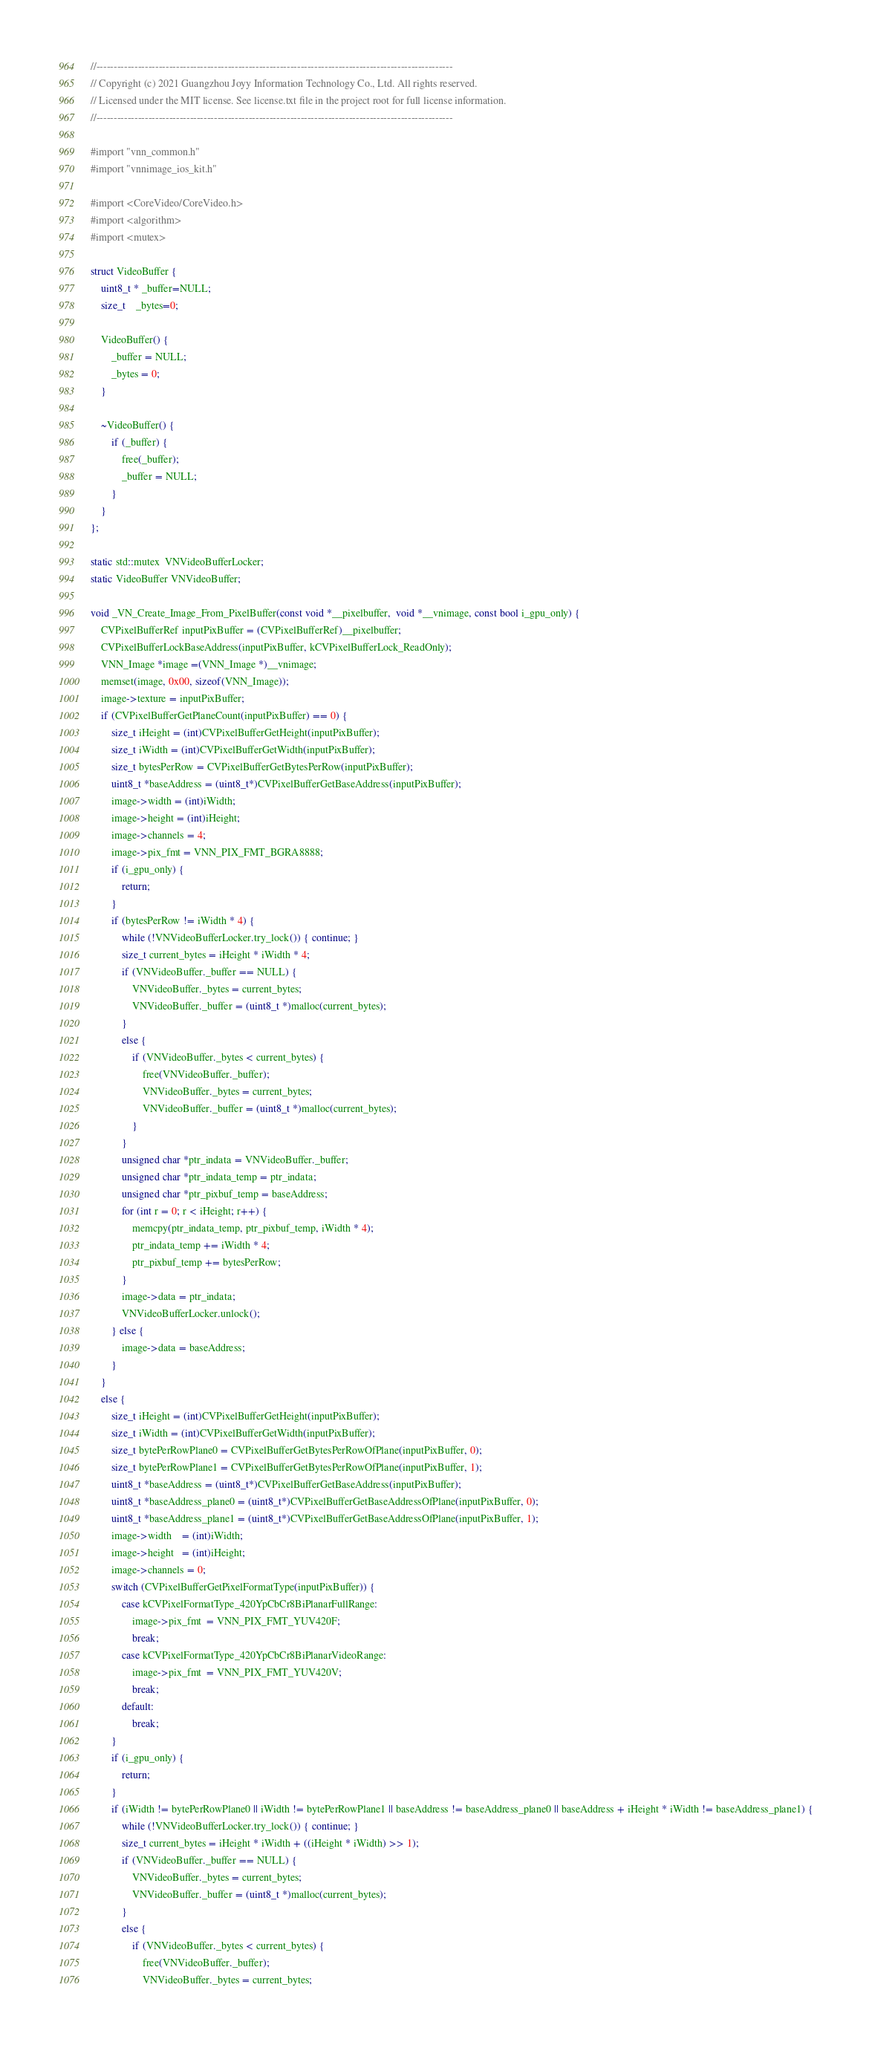<code> <loc_0><loc_0><loc_500><loc_500><_ObjectiveC_>//-------------------------------------------------------------------------------------------------------
// Copyright (c) 2021 Guangzhou Joyy Information Technology Co., Ltd. All rights reserved.
// Licensed under the MIT license. See license.txt file in the project root for full license information.
//-------------------------------------------------------------------------------------------------------

#import "vnn_common.h"
#import "vnnimage_ios_kit.h"

#import <CoreVideo/CoreVideo.h>
#import <algorithm>
#import <mutex>

struct VideoBuffer {
    uint8_t * _buffer=NULL;
    size_t    _bytes=0;

    VideoBuffer() {
        _buffer = NULL;
        _bytes = 0;
    }

    ~VideoBuffer() {
        if (_buffer) {
            free(_buffer);
            _buffer = NULL;
        }
    }
};

static std::mutex  VNVideoBufferLocker;
static VideoBuffer VNVideoBuffer;

void _VN_Create_Image_From_PixelBuffer(const void *__pixelbuffer,  void *__vnimage, const bool i_gpu_only) {
    CVPixelBufferRef inputPixBuffer = (CVPixelBufferRef)__pixelbuffer;
    CVPixelBufferLockBaseAddress(inputPixBuffer, kCVPixelBufferLock_ReadOnly);
    VNN_Image *image =(VNN_Image *)__vnimage;
	memset(image, 0x00, sizeof(VNN_Image));
    image->texture = inputPixBuffer;
	if (CVPixelBufferGetPlaneCount(inputPixBuffer) == 0) {
		size_t iHeight = (int)CVPixelBufferGetHeight(inputPixBuffer);
		size_t iWidth = (int)CVPixelBufferGetWidth(inputPixBuffer);
		size_t bytesPerRow = CVPixelBufferGetBytesPerRow(inputPixBuffer);
		uint8_t *baseAddress = (uint8_t*)CVPixelBufferGetBaseAddress(inputPixBuffer);
		image->width = (int)iWidth;
		image->height = (int)iHeight;
		image->channels = 4;
		image->pix_fmt = VNN_PIX_FMT_BGRA8888;
        if (i_gpu_only) {
            return;
        }
		if (bytesPerRow != iWidth * 4) {
            while (!VNVideoBufferLocker.try_lock()) { continue; }
            size_t current_bytes = iHeight * iWidth * 4;
            if (VNVideoBuffer._buffer == NULL) {
                VNVideoBuffer._bytes = current_bytes;
                VNVideoBuffer._buffer = (uint8_t *)malloc(current_bytes);
            }
            else {
                if (VNVideoBuffer._bytes < current_bytes) {
                    free(VNVideoBuffer._buffer);
                    VNVideoBuffer._bytes = current_bytes;
                    VNVideoBuffer._buffer = (uint8_t *)malloc(current_bytes);
                }
            }
			unsigned char *ptr_indata = VNVideoBuffer._buffer;
			unsigned char *ptr_indata_temp = ptr_indata;
			unsigned char *ptr_pixbuf_temp = baseAddress;
			for (int r = 0; r < iHeight; r++) {
				memcpy(ptr_indata_temp, ptr_pixbuf_temp, iWidth * 4);
				ptr_indata_temp += iWidth * 4;
				ptr_pixbuf_temp += bytesPerRow;
			}
			image->data = ptr_indata;
            VNVideoBufferLocker.unlock();
		} else {
			image->data = baseAddress;
		}
	}
	else {
		size_t iHeight = (int)CVPixelBufferGetHeight(inputPixBuffer);
		size_t iWidth = (int)CVPixelBufferGetWidth(inputPixBuffer);
		size_t bytePerRowPlane0 = CVPixelBufferGetBytesPerRowOfPlane(inputPixBuffer, 0);
		size_t bytePerRowPlane1 = CVPixelBufferGetBytesPerRowOfPlane(inputPixBuffer, 1);
		uint8_t *baseAddress = (uint8_t*)CVPixelBufferGetBaseAddress(inputPixBuffer);
		uint8_t *baseAddress_plane0 = (uint8_t*)CVPixelBufferGetBaseAddressOfPlane(inputPixBuffer, 0);
		uint8_t *baseAddress_plane1 = (uint8_t*)CVPixelBufferGetBaseAddressOfPlane(inputPixBuffer, 1);
		image->width    = (int)iWidth;
		image->height   = (int)iHeight;
		image->channels = 0;
		switch (CVPixelBufferGetPixelFormatType(inputPixBuffer)) {
			case kCVPixelFormatType_420YpCbCr8BiPlanarFullRange:
				image->pix_fmt  = VNN_PIX_FMT_YUV420F;
				break;
			case kCVPixelFormatType_420YpCbCr8BiPlanarVideoRange:
				image->pix_fmt  = VNN_PIX_FMT_YUV420V;
				break;
			default:
				break;
		}
        if (i_gpu_only) {
            return;
        }
		if (iWidth != bytePerRowPlane0 || iWidth != bytePerRowPlane1 || baseAddress != baseAddress_plane0 || baseAddress + iHeight * iWidth != baseAddress_plane1) {
            while (!VNVideoBufferLocker.try_lock()) { continue; }
            size_t current_bytes = iHeight * iWidth + ((iHeight * iWidth) >> 1);
            if (VNVideoBuffer._buffer == NULL) {
                VNVideoBuffer._bytes = current_bytes;
                VNVideoBuffer._buffer = (uint8_t *)malloc(current_bytes);
            }
            else {
                if (VNVideoBuffer._bytes < current_bytes) {
                    free(VNVideoBuffer._buffer);
                    VNVideoBuffer._bytes = current_bytes;</code> 